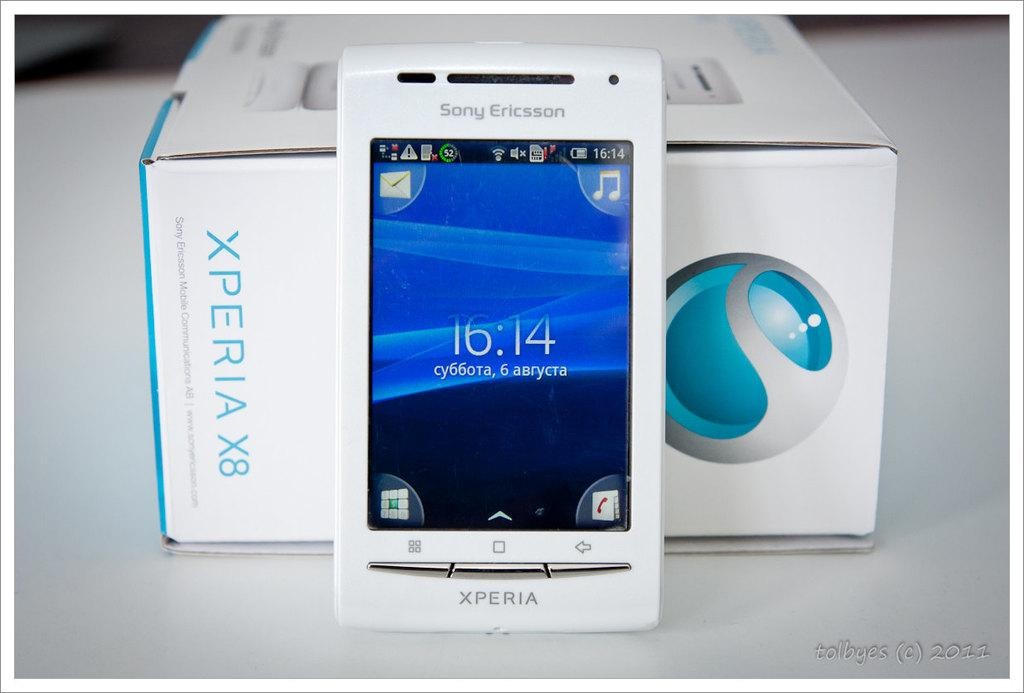<image>
Give a short and clear explanation of the subsequent image. A white Sony Xperia smartphone propped up against the packaging box for it. 